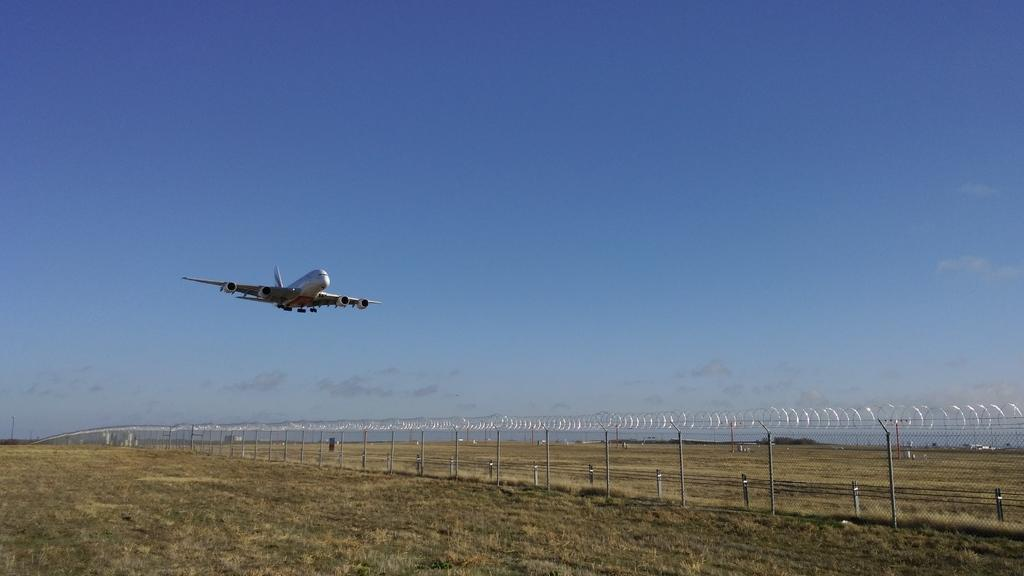What is the main subject in the middle of the image? There is an airplane in the middle of the image. What color is the sky visible at the top of the image? The sky is blue in the image. What can be seen on the right side of the image? There are electrical wires on the right side of the image. What type of texture can be seen on the orange in the image? There is no orange present in the image, so it is not possible to determine its texture. 